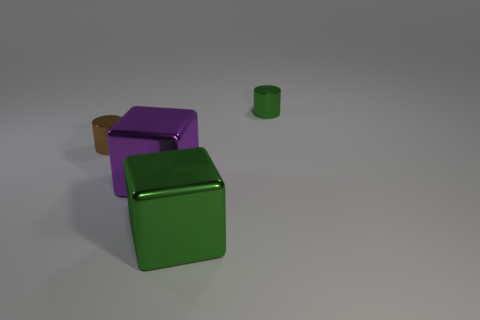Add 3 brown matte spheres. How many objects exist? 7 Subtract 0 green balls. How many objects are left? 4 Subtract all blocks. Subtract all tiny green objects. How many objects are left? 1 Add 2 green cubes. How many green cubes are left? 3 Add 1 green cylinders. How many green cylinders exist? 2 